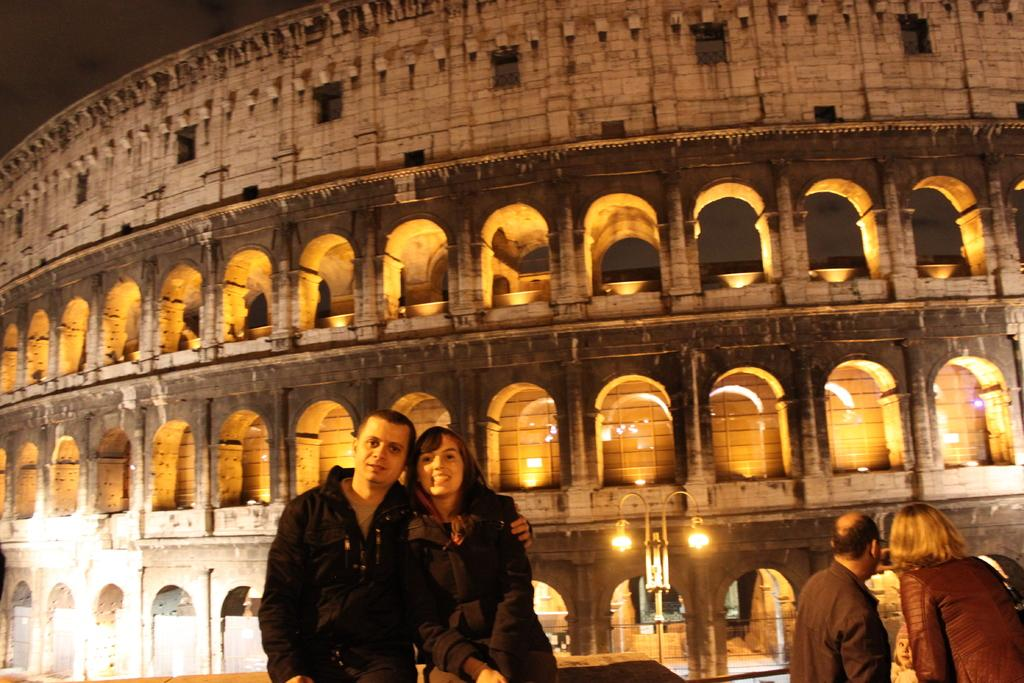How many people are in the image? There are people in the image. Can you describe the expressions of some of the people? Two of the people are smiling. What are the smiling people wearing? Both smiling people are wearing black dresses. What famous landmark can be seen in the background of the image? The Colosseum is visible in the background of the image. Where is the house located in the image? There is no mention of a house in the image. 